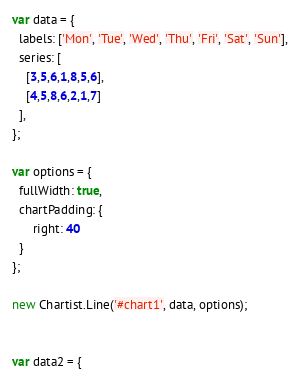Convert code to text. <code><loc_0><loc_0><loc_500><loc_500><_JavaScript_>var data = {
  labels: ['Mon', 'Tue', 'Wed', 'Thu', 'Fri', 'Sat', 'Sun'],
  series: [
    [3,5,6,1,8,5,6],
    [4,5,8,6,2,1,7]
  ],
};

var options = {
  fullWidth: true,
  chartPadding: {
	  right: 40
  }
};

new Chartist.Line('#chart1', data, options);


var data2 = {</code> 